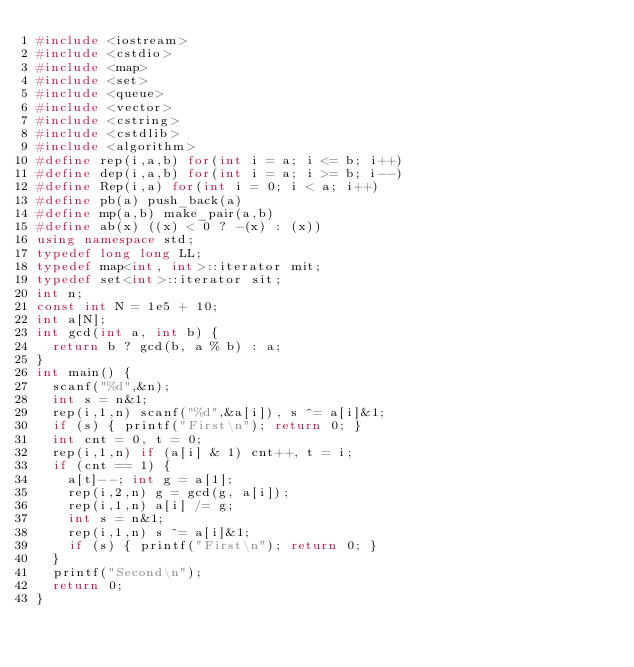Convert code to text. <code><loc_0><loc_0><loc_500><loc_500><_C++_>#include <iostream>
#include <cstdio>
#include <map>
#include <set>
#include <queue>
#include <vector>
#include <cstring>
#include <cstdlib>
#include <algorithm>
#define rep(i,a,b) for(int i = a; i <= b; i++)
#define dep(i,a,b) for(int i = a; i >= b; i--) 
#define Rep(i,a) for(int i = 0; i < a; i++)
#define pb(a) push_back(a)
#define mp(a,b) make_pair(a,b)
#define ab(x) ((x) < 0 ? -(x) : (x))
using namespace std;
typedef long long LL;
typedef map<int, int>::iterator mit;
typedef set<int>::iterator sit;
int n;
const int N = 1e5 + 10;
int a[N];
int gcd(int a, int b) {
	return b ? gcd(b, a % b) : a; 
}
int main() {
	scanf("%d",&n);
	int s = n&1;
	rep(i,1,n) scanf("%d",&a[i]), s ^= a[i]&1;
	if (s) { printf("First\n"); return 0; }
	int cnt = 0, t = 0;
	rep(i,1,n) if (a[i] & 1) cnt++, t = i;
	if (cnt == 1) {
		a[t]--; int g = a[1];
		rep(i,2,n) g = gcd(g, a[i]);
		rep(i,1,n) a[i] /= g;
		int s = n&1;
		rep(i,1,n) s ^= a[i]&1;
		if (s) { printf("First\n"); return 0; }
	}
	printf("Second\n");
	return 0;
}
</code> 